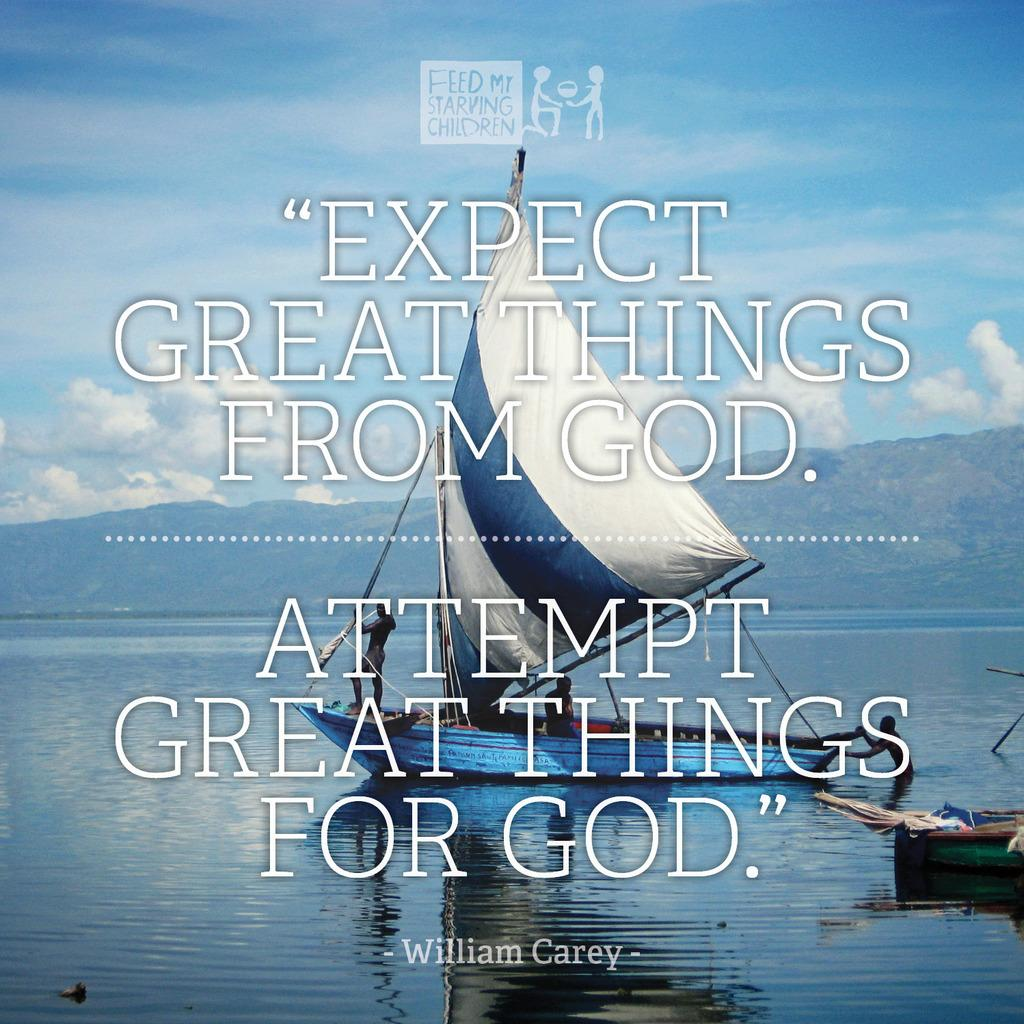<image>
Offer a succinct explanation of the picture presented. A sailboat on a vast body of water with a quote from William Carey superimposed over the scene that reads "Expect great things from God. Attempt great things for God." 